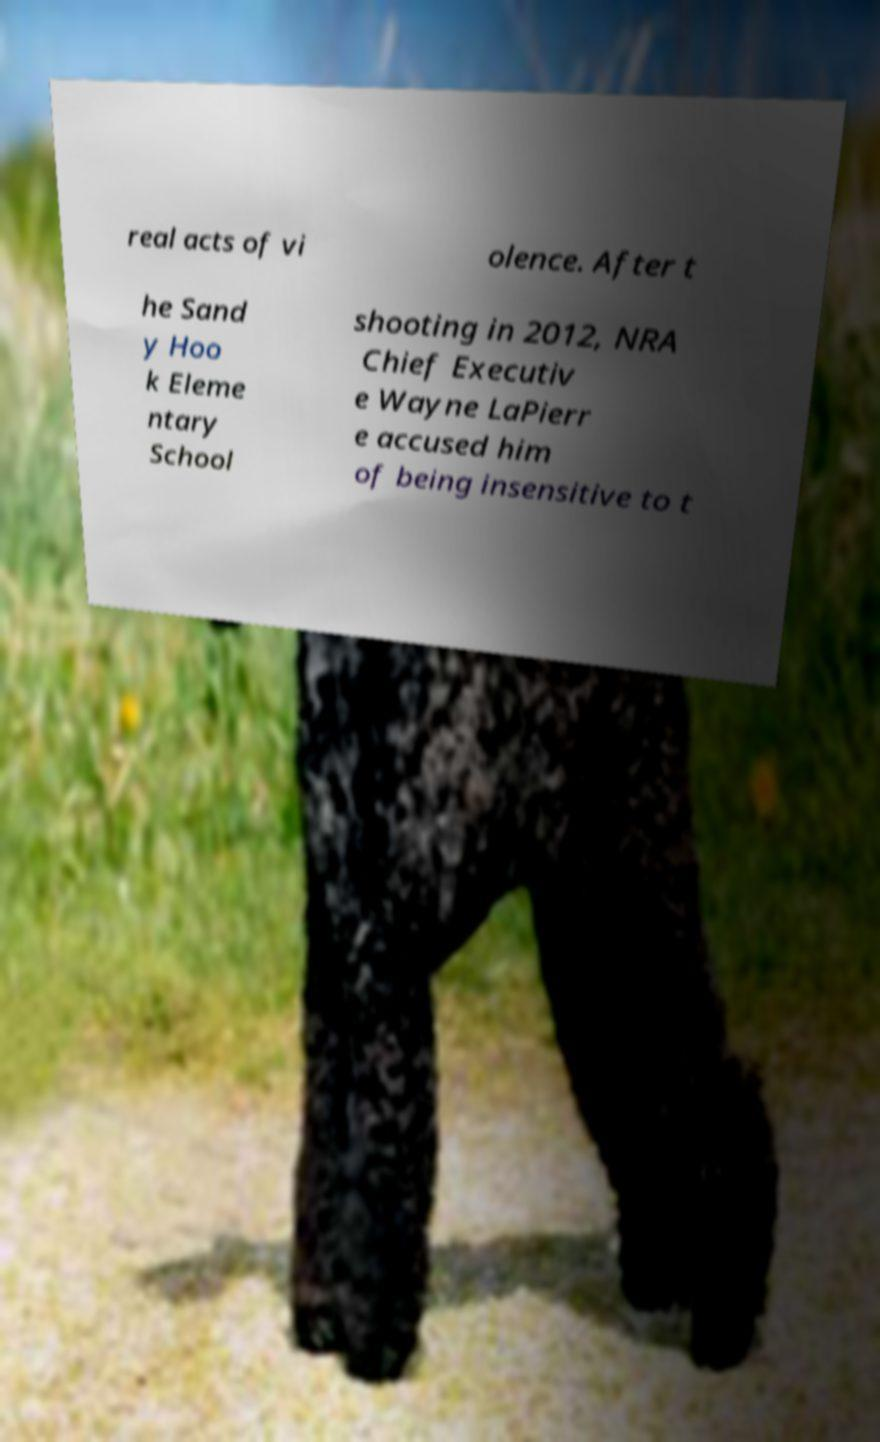I need the written content from this picture converted into text. Can you do that? real acts of vi olence. After t he Sand y Hoo k Eleme ntary School shooting in 2012, NRA Chief Executiv e Wayne LaPierr e accused him of being insensitive to t 